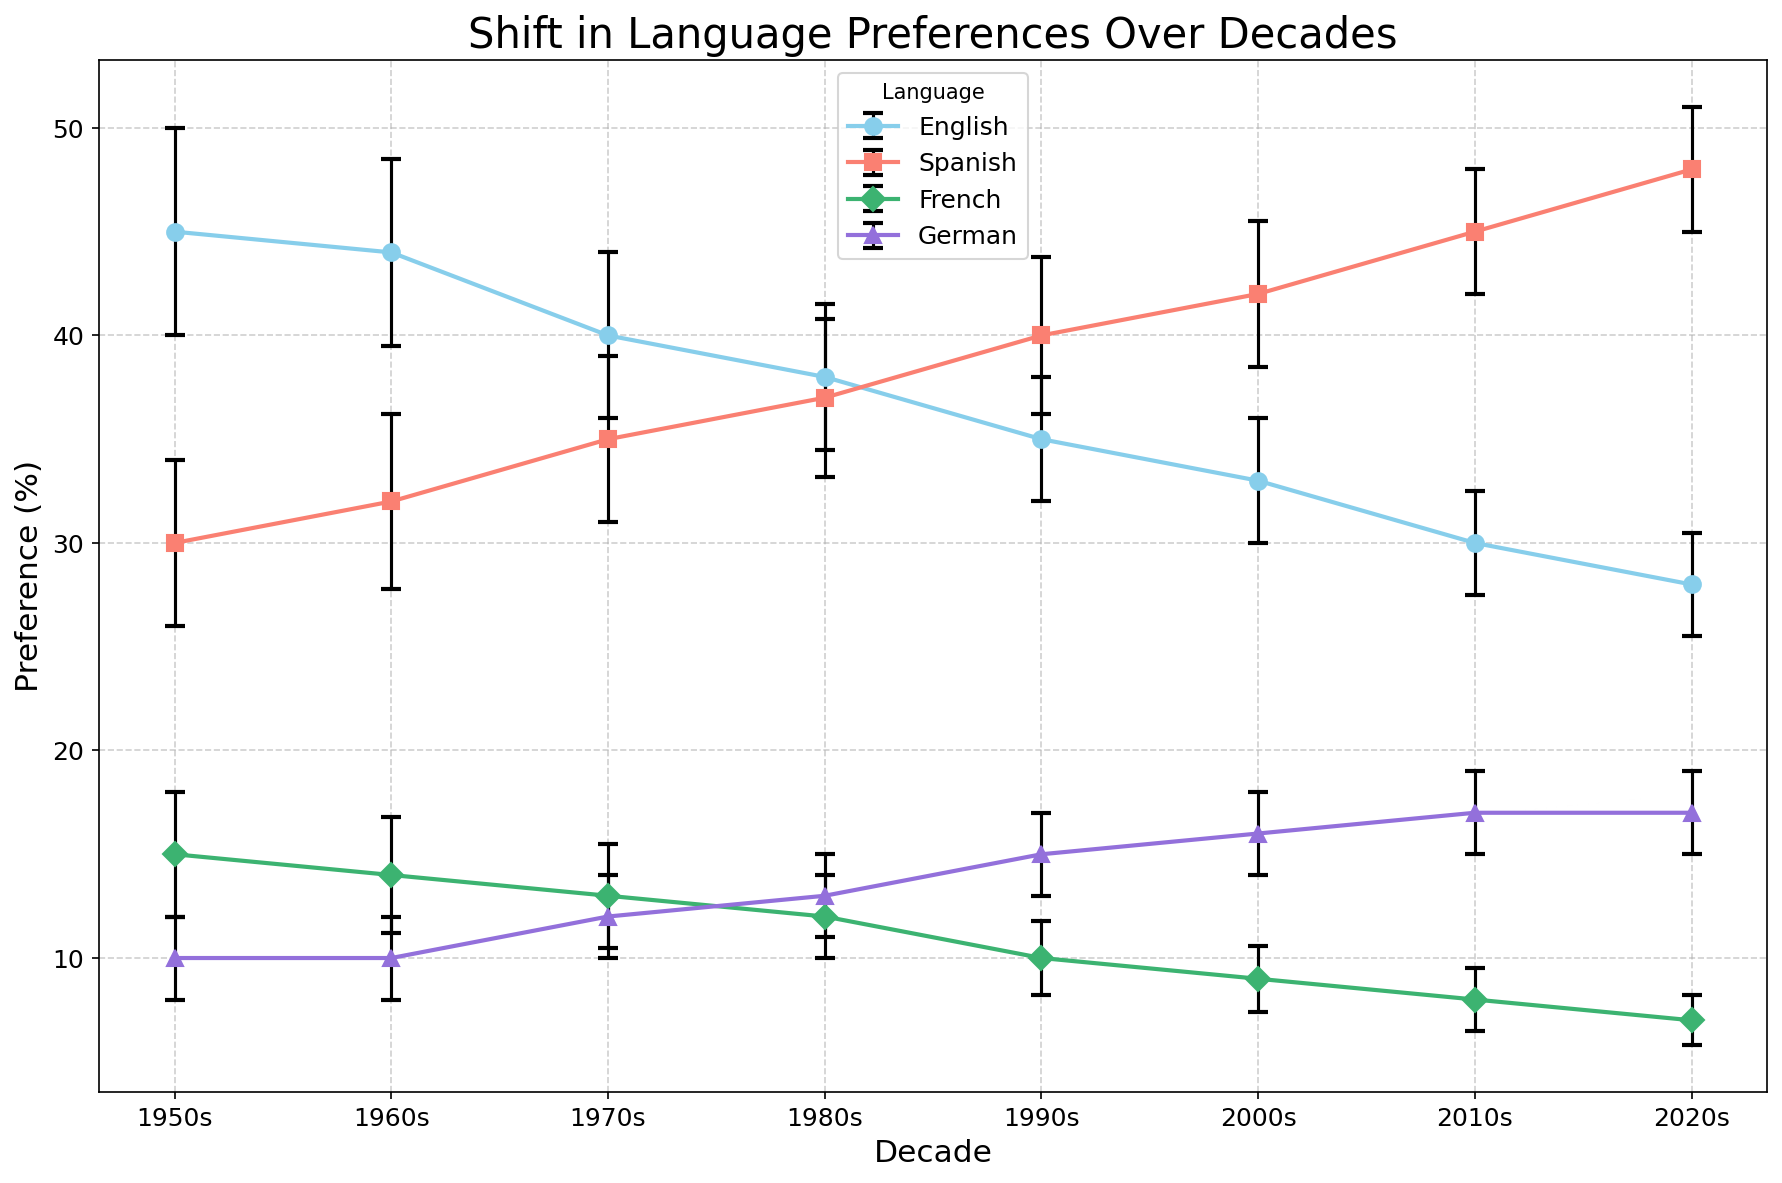How has the preference for English changed from the 1950s to the 2020s? The chart shows that the preference for English has declined from 45% in the 1950s to 28% in the 2020s.
Answer: Declined Which language had the highest increase in preference from the 1950s to the 2020s? Based on the chart, Spanish shows an increase in preference from 30% in the 1950s to 48% in the 2020s, which is the largest increase among the languages.
Answer: Spanish In which decade did Spanish surpass English in preference? The chart indicates that Spanish surpassed English in the 1990s, where Spanish had 40% preference and English had 35%.
Answer: 1990s What is the average preference for German across all the decades shown? The preferences for German across the decades are 10%, 10%, 12%, 13%, 15%, 16%, 17%, and 17%. The average is calculated as (10 + 10 + 12 + 13 + 15 + 16 + 17 + 17) / 8 = 13.75%.
Answer: 13.75% Which language shows the greatest stability in preference (i.e., the smallest change) over the decades? The preference for German starts at 10% in the 1950s and ends at 17% in the 2020s, which is the smallest change (7%) compared to other languages.
Answer: German In which decade did French have its highest preference, and what was the value? The chart shows that French had its highest preference in the 1950s with a value of 15%.
Answer: 1950s, 15% How does the error margin for Spanish in the 2010s compare to the error margin for English in the same decade? The error margin for Spanish in the 2010s is 3%, while for English it is 2.5%. Therefore, Spanish has a higher error margin by 0.5%.
Answer: Spanish has a higher error margin by 0.5% What's the difference in preference for French between the 1950s and the 2020s? The chart shows the preference for French was 15% in the 1950s and 7% in the 2020s. The difference is 15% - 7% = 8%.
Answer: 8% If the preferences in the 1970s for French and German are combined, how do they compare to the preference for Spanish in the same decade? The preferences for French and German in the 1970s are 13% and 12%, respectively. Combined, they are 13% + 12% = 25%. The preference for Spanish in the 1970s is 35%. Therefore, Spanish still has a higher preference by 10%.
Answer: Spanish is higher by 10% 